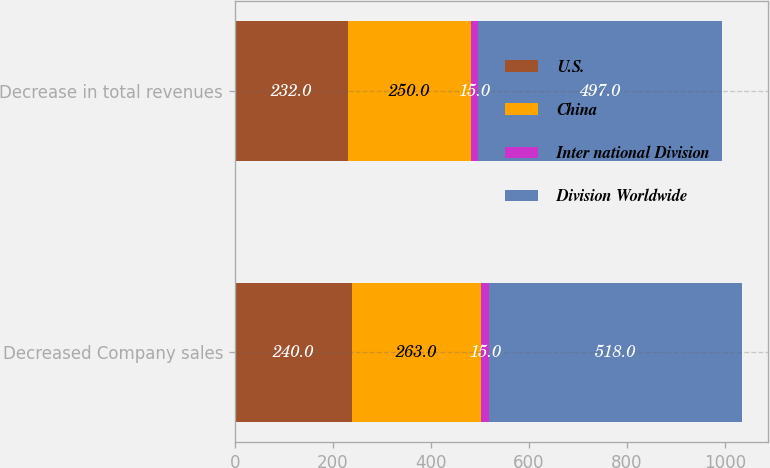Convert chart to OTSL. <chart><loc_0><loc_0><loc_500><loc_500><stacked_bar_chart><ecel><fcel>Decreased Company sales<fcel>Decrease in total revenues<nl><fcel>U.S.<fcel>240<fcel>232<nl><fcel>China<fcel>263<fcel>250<nl><fcel>Inter national Division<fcel>15<fcel>15<nl><fcel>Division Worldwide<fcel>518<fcel>497<nl></chart> 